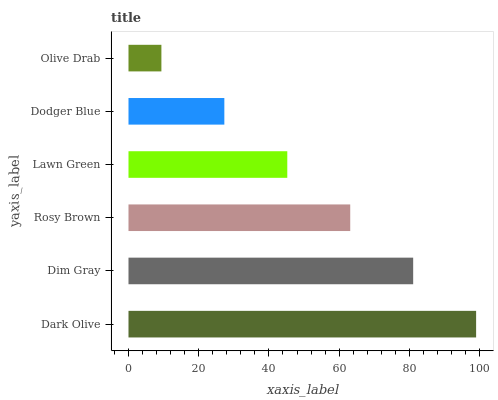Is Olive Drab the minimum?
Answer yes or no. Yes. Is Dark Olive the maximum?
Answer yes or no. Yes. Is Dim Gray the minimum?
Answer yes or no. No. Is Dim Gray the maximum?
Answer yes or no. No. Is Dark Olive greater than Dim Gray?
Answer yes or no. Yes. Is Dim Gray less than Dark Olive?
Answer yes or no. Yes. Is Dim Gray greater than Dark Olive?
Answer yes or no. No. Is Dark Olive less than Dim Gray?
Answer yes or no. No. Is Rosy Brown the high median?
Answer yes or no. Yes. Is Lawn Green the low median?
Answer yes or no. Yes. Is Dim Gray the high median?
Answer yes or no. No. Is Dark Olive the low median?
Answer yes or no. No. 